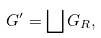<formula> <loc_0><loc_0><loc_500><loc_500>G ^ { \prime } = \bigsqcup G _ { R } ,</formula> 